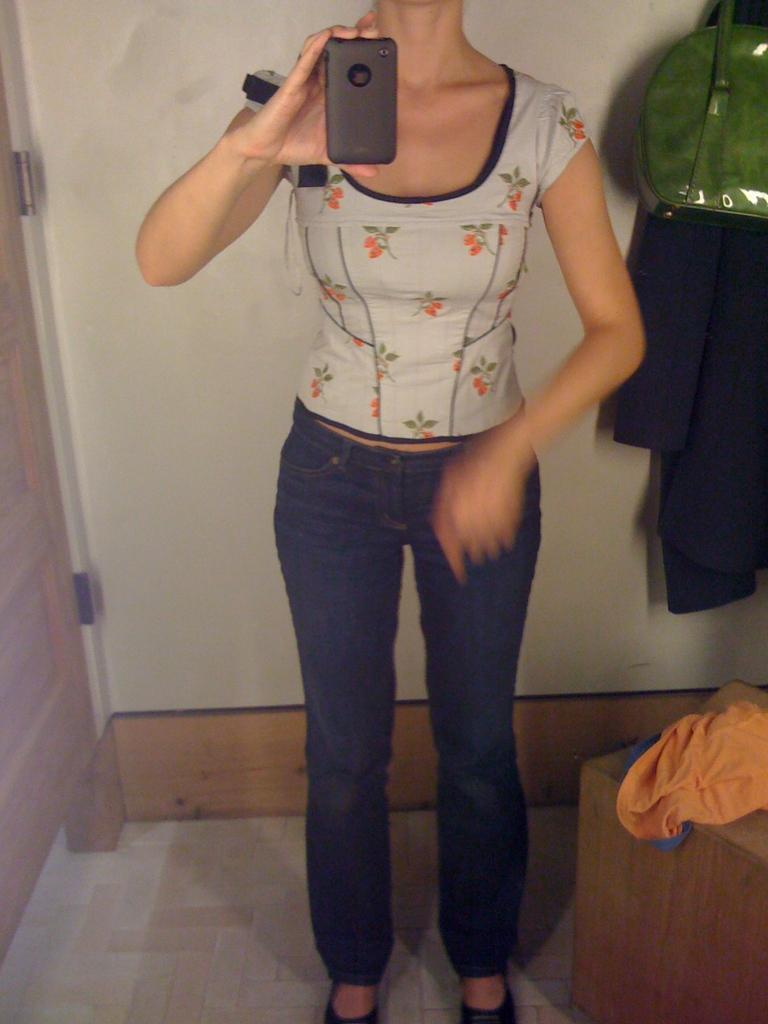What is the woman in the image doing? The woman is standing in the image and holding a mobile. What is the woman holding in her hand? The woman is holding a mobile. What can be seen on the wooden surface beside the woman? There are clothes on a wooden surface beside the woman. What is visible in the background of the image? There is a wall, cloth, and a green bag in the background of the image. What type of bun is the woman eating in the image? There is no bun present in the image; the woman is holding a mobile. Can you tell me how many strangers are visible in the image? There are no strangers visible in the image; the only person present is the woman. 